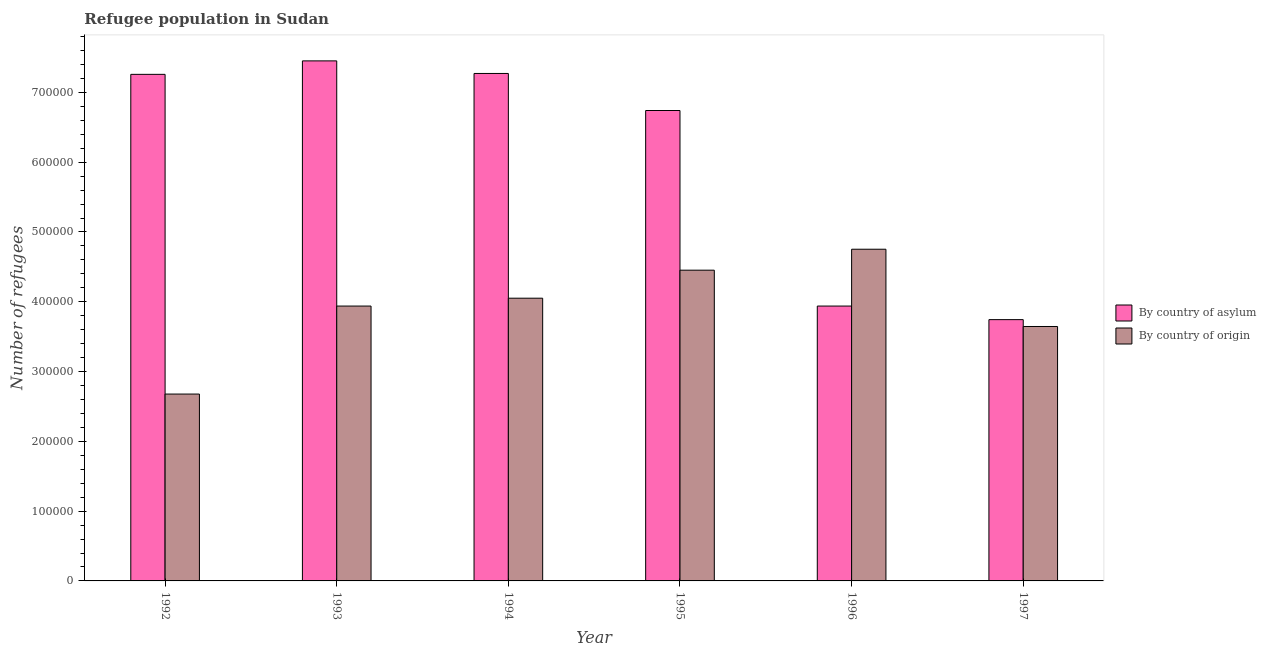How many different coloured bars are there?
Your response must be concise. 2. Are the number of bars on each tick of the X-axis equal?
Provide a short and direct response. Yes. How many bars are there on the 2nd tick from the left?
Your answer should be compact. 2. How many bars are there on the 4th tick from the right?
Offer a terse response. 2. In how many cases, is the number of bars for a given year not equal to the number of legend labels?
Give a very brief answer. 0. What is the number of refugees by country of origin in 1993?
Your answer should be very brief. 3.94e+05. Across all years, what is the maximum number of refugees by country of asylum?
Provide a succinct answer. 7.45e+05. Across all years, what is the minimum number of refugees by country of origin?
Keep it short and to the point. 2.68e+05. In which year was the number of refugees by country of origin maximum?
Provide a succinct answer. 1996. In which year was the number of refugees by country of origin minimum?
Make the answer very short. 1992. What is the total number of refugees by country of origin in the graph?
Keep it short and to the point. 2.35e+06. What is the difference between the number of refugees by country of asylum in 1993 and that in 1997?
Give a very brief answer. 3.71e+05. What is the difference between the number of refugees by country of asylum in 1994 and the number of refugees by country of origin in 1995?
Make the answer very short. 5.31e+04. What is the average number of refugees by country of asylum per year?
Offer a very short reply. 6.07e+05. In how many years, is the number of refugees by country of asylum greater than 140000?
Ensure brevity in your answer.  6. What is the ratio of the number of refugees by country of asylum in 1994 to that in 1997?
Make the answer very short. 1.94. Is the number of refugees by country of asylum in 1995 less than that in 1997?
Your response must be concise. No. Is the difference between the number of refugees by country of origin in 1993 and 1995 greater than the difference between the number of refugees by country of asylum in 1993 and 1995?
Offer a terse response. No. What is the difference between the highest and the second highest number of refugees by country of origin?
Make the answer very short. 3.00e+04. What is the difference between the highest and the lowest number of refugees by country of origin?
Provide a short and direct response. 2.08e+05. In how many years, is the number of refugees by country of origin greater than the average number of refugees by country of origin taken over all years?
Your answer should be compact. 4. What does the 2nd bar from the left in 1995 represents?
Make the answer very short. By country of origin. What does the 2nd bar from the right in 1993 represents?
Provide a short and direct response. By country of asylum. How many bars are there?
Make the answer very short. 12. What is the difference between two consecutive major ticks on the Y-axis?
Your answer should be compact. 1.00e+05. Does the graph contain grids?
Make the answer very short. No. Where does the legend appear in the graph?
Your answer should be very brief. Center right. What is the title of the graph?
Provide a succinct answer. Refugee population in Sudan. Does "Start a business" appear as one of the legend labels in the graph?
Provide a short and direct response. No. What is the label or title of the X-axis?
Make the answer very short. Year. What is the label or title of the Y-axis?
Your answer should be compact. Number of refugees. What is the Number of refugees in By country of asylum in 1992?
Ensure brevity in your answer.  7.26e+05. What is the Number of refugees of By country of origin in 1992?
Your response must be concise. 2.68e+05. What is the Number of refugees of By country of asylum in 1993?
Give a very brief answer. 7.45e+05. What is the Number of refugees in By country of origin in 1993?
Offer a very short reply. 3.94e+05. What is the Number of refugees in By country of asylum in 1994?
Make the answer very short. 7.27e+05. What is the Number of refugees of By country of origin in 1994?
Your answer should be compact. 4.05e+05. What is the Number of refugees of By country of asylum in 1995?
Your answer should be very brief. 6.74e+05. What is the Number of refugees of By country of origin in 1995?
Your response must be concise. 4.45e+05. What is the Number of refugees of By country of asylum in 1996?
Keep it short and to the point. 3.94e+05. What is the Number of refugees in By country of origin in 1996?
Provide a succinct answer. 4.75e+05. What is the Number of refugees of By country of asylum in 1997?
Your response must be concise. 3.74e+05. What is the Number of refugees of By country of origin in 1997?
Your response must be concise. 3.65e+05. Across all years, what is the maximum Number of refugees in By country of asylum?
Offer a terse response. 7.45e+05. Across all years, what is the maximum Number of refugees in By country of origin?
Make the answer very short. 4.75e+05. Across all years, what is the minimum Number of refugees in By country of asylum?
Ensure brevity in your answer.  3.74e+05. Across all years, what is the minimum Number of refugees in By country of origin?
Make the answer very short. 2.68e+05. What is the total Number of refugees of By country of asylum in the graph?
Ensure brevity in your answer.  3.64e+06. What is the total Number of refugees of By country of origin in the graph?
Provide a short and direct response. 2.35e+06. What is the difference between the Number of refugees of By country of asylum in 1992 and that in 1993?
Provide a succinct answer. -1.93e+04. What is the difference between the Number of refugees of By country of origin in 1992 and that in 1993?
Ensure brevity in your answer.  -1.26e+05. What is the difference between the Number of refugees of By country of asylum in 1992 and that in 1994?
Your response must be concise. -1274. What is the difference between the Number of refugees in By country of origin in 1992 and that in 1994?
Make the answer very short. -1.37e+05. What is the difference between the Number of refugees in By country of asylum in 1992 and that in 1995?
Offer a very short reply. 5.18e+04. What is the difference between the Number of refugees in By country of origin in 1992 and that in 1995?
Give a very brief answer. -1.78e+05. What is the difference between the Number of refugees in By country of asylum in 1992 and that in 1996?
Give a very brief answer. 3.32e+05. What is the difference between the Number of refugees of By country of origin in 1992 and that in 1996?
Offer a terse response. -2.08e+05. What is the difference between the Number of refugees of By country of asylum in 1992 and that in 1997?
Your answer should be compact. 3.51e+05. What is the difference between the Number of refugees of By country of origin in 1992 and that in 1997?
Make the answer very short. -9.68e+04. What is the difference between the Number of refugees in By country of asylum in 1993 and that in 1994?
Your answer should be very brief. 1.80e+04. What is the difference between the Number of refugees of By country of origin in 1993 and that in 1994?
Ensure brevity in your answer.  -1.13e+04. What is the difference between the Number of refugees of By country of asylum in 1993 and that in 1995?
Your answer should be very brief. 7.11e+04. What is the difference between the Number of refugees of By country of origin in 1993 and that in 1995?
Your response must be concise. -5.14e+04. What is the difference between the Number of refugees in By country of asylum in 1993 and that in 1996?
Offer a very short reply. 3.51e+05. What is the difference between the Number of refugees of By country of origin in 1993 and that in 1996?
Offer a terse response. -8.14e+04. What is the difference between the Number of refugees in By country of asylum in 1993 and that in 1997?
Make the answer very short. 3.71e+05. What is the difference between the Number of refugees in By country of origin in 1993 and that in 1997?
Provide a short and direct response. 2.93e+04. What is the difference between the Number of refugees of By country of asylum in 1994 and that in 1995?
Give a very brief answer. 5.31e+04. What is the difference between the Number of refugees in By country of origin in 1994 and that in 1995?
Offer a terse response. -4.01e+04. What is the difference between the Number of refugees in By country of asylum in 1994 and that in 1996?
Make the answer very short. 3.33e+05. What is the difference between the Number of refugees in By country of origin in 1994 and that in 1996?
Ensure brevity in your answer.  -7.02e+04. What is the difference between the Number of refugees in By country of asylum in 1994 and that in 1997?
Your answer should be very brief. 3.53e+05. What is the difference between the Number of refugees of By country of origin in 1994 and that in 1997?
Your answer should be very brief. 4.05e+04. What is the difference between the Number of refugees in By country of asylum in 1995 and that in 1996?
Keep it short and to the point. 2.80e+05. What is the difference between the Number of refugees of By country of origin in 1995 and that in 1996?
Offer a terse response. -3.00e+04. What is the difference between the Number of refugees of By country of asylum in 1995 and that in 1997?
Keep it short and to the point. 3.00e+05. What is the difference between the Number of refugees of By country of origin in 1995 and that in 1997?
Provide a short and direct response. 8.07e+04. What is the difference between the Number of refugees in By country of asylum in 1996 and that in 1997?
Keep it short and to the point. 1.95e+04. What is the difference between the Number of refugees of By country of origin in 1996 and that in 1997?
Your answer should be compact. 1.11e+05. What is the difference between the Number of refugees in By country of asylum in 1992 and the Number of refugees in By country of origin in 1993?
Make the answer very short. 3.32e+05. What is the difference between the Number of refugees in By country of asylum in 1992 and the Number of refugees in By country of origin in 1994?
Provide a short and direct response. 3.21e+05. What is the difference between the Number of refugees in By country of asylum in 1992 and the Number of refugees in By country of origin in 1995?
Your response must be concise. 2.81e+05. What is the difference between the Number of refugees of By country of asylum in 1992 and the Number of refugees of By country of origin in 1996?
Offer a terse response. 2.51e+05. What is the difference between the Number of refugees in By country of asylum in 1992 and the Number of refugees in By country of origin in 1997?
Ensure brevity in your answer.  3.61e+05. What is the difference between the Number of refugees of By country of asylum in 1993 and the Number of refugees of By country of origin in 1994?
Offer a very short reply. 3.40e+05. What is the difference between the Number of refugees of By country of asylum in 1993 and the Number of refugees of By country of origin in 1995?
Offer a very short reply. 3.00e+05. What is the difference between the Number of refugees in By country of asylum in 1993 and the Number of refugees in By country of origin in 1996?
Your answer should be very brief. 2.70e+05. What is the difference between the Number of refugees in By country of asylum in 1993 and the Number of refugees in By country of origin in 1997?
Offer a terse response. 3.81e+05. What is the difference between the Number of refugees of By country of asylum in 1994 and the Number of refugees of By country of origin in 1995?
Your response must be concise. 2.82e+05. What is the difference between the Number of refugees of By country of asylum in 1994 and the Number of refugees of By country of origin in 1996?
Your answer should be very brief. 2.52e+05. What is the difference between the Number of refugees in By country of asylum in 1994 and the Number of refugees in By country of origin in 1997?
Offer a terse response. 3.63e+05. What is the difference between the Number of refugees in By country of asylum in 1995 and the Number of refugees in By country of origin in 1996?
Your response must be concise. 1.99e+05. What is the difference between the Number of refugees in By country of asylum in 1995 and the Number of refugees in By country of origin in 1997?
Ensure brevity in your answer.  3.09e+05. What is the difference between the Number of refugees in By country of asylum in 1996 and the Number of refugees in By country of origin in 1997?
Make the answer very short. 2.93e+04. What is the average Number of refugees of By country of asylum per year?
Ensure brevity in your answer.  6.07e+05. What is the average Number of refugees of By country of origin per year?
Your answer should be very brief. 3.92e+05. In the year 1992, what is the difference between the Number of refugees of By country of asylum and Number of refugees of By country of origin?
Your answer should be very brief. 4.58e+05. In the year 1993, what is the difference between the Number of refugees of By country of asylum and Number of refugees of By country of origin?
Ensure brevity in your answer.  3.51e+05. In the year 1994, what is the difference between the Number of refugees of By country of asylum and Number of refugees of By country of origin?
Offer a terse response. 3.22e+05. In the year 1995, what is the difference between the Number of refugees in By country of asylum and Number of refugees in By country of origin?
Your answer should be very brief. 2.29e+05. In the year 1996, what is the difference between the Number of refugees in By country of asylum and Number of refugees in By country of origin?
Offer a terse response. -8.14e+04. In the year 1997, what is the difference between the Number of refugees of By country of asylum and Number of refugees of By country of origin?
Keep it short and to the point. 9826. What is the ratio of the Number of refugees of By country of asylum in 1992 to that in 1993?
Offer a very short reply. 0.97. What is the ratio of the Number of refugees in By country of origin in 1992 to that in 1993?
Offer a very short reply. 0.68. What is the ratio of the Number of refugees of By country of asylum in 1992 to that in 1994?
Offer a terse response. 1. What is the ratio of the Number of refugees of By country of origin in 1992 to that in 1994?
Provide a succinct answer. 0.66. What is the ratio of the Number of refugees of By country of asylum in 1992 to that in 1995?
Your answer should be compact. 1.08. What is the ratio of the Number of refugees in By country of origin in 1992 to that in 1995?
Your response must be concise. 0.6. What is the ratio of the Number of refugees of By country of asylum in 1992 to that in 1996?
Offer a terse response. 1.84. What is the ratio of the Number of refugees in By country of origin in 1992 to that in 1996?
Offer a very short reply. 0.56. What is the ratio of the Number of refugees in By country of asylum in 1992 to that in 1997?
Offer a terse response. 1.94. What is the ratio of the Number of refugees in By country of origin in 1992 to that in 1997?
Provide a short and direct response. 0.73. What is the ratio of the Number of refugees of By country of asylum in 1993 to that in 1994?
Make the answer very short. 1.02. What is the ratio of the Number of refugees in By country of origin in 1993 to that in 1994?
Offer a very short reply. 0.97. What is the ratio of the Number of refugees in By country of asylum in 1993 to that in 1995?
Offer a terse response. 1.11. What is the ratio of the Number of refugees in By country of origin in 1993 to that in 1995?
Your answer should be very brief. 0.88. What is the ratio of the Number of refugees in By country of asylum in 1993 to that in 1996?
Offer a terse response. 1.89. What is the ratio of the Number of refugees in By country of origin in 1993 to that in 1996?
Provide a short and direct response. 0.83. What is the ratio of the Number of refugees in By country of asylum in 1993 to that in 1997?
Your answer should be very brief. 1.99. What is the ratio of the Number of refugees in By country of origin in 1993 to that in 1997?
Keep it short and to the point. 1.08. What is the ratio of the Number of refugees of By country of asylum in 1994 to that in 1995?
Offer a very short reply. 1.08. What is the ratio of the Number of refugees of By country of origin in 1994 to that in 1995?
Provide a short and direct response. 0.91. What is the ratio of the Number of refugees of By country of asylum in 1994 to that in 1996?
Your response must be concise. 1.85. What is the ratio of the Number of refugees in By country of origin in 1994 to that in 1996?
Offer a very short reply. 0.85. What is the ratio of the Number of refugees in By country of asylum in 1994 to that in 1997?
Your response must be concise. 1.94. What is the ratio of the Number of refugees in By country of origin in 1994 to that in 1997?
Provide a succinct answer. 1.11. What is the ratio of the Number of refugees of By country of asylum in 1995 to that in 1996?
Provide a succinct answer. 1.71. What is the ratio of the Number of refugees in By country of origin in 1995 to that in 1996?
Give a very brief answer. 0.94. What is the ratio of the Number of refugees in By country of asylum in 1995 to that in 1997?
Offer a very short reply. 1.8. What is the ratio of the Number of refugees of By country of origin in 1995 to that in 1997?
Provide a succinct answer. 1.22. What is the ratio of the Number of refugees of By country of asylum in 1996 to that in 1997?
Offer a terse response. 1.05. What is the ratio of the Number of refugees in By country of origin in 1996 to that in 1997?
Offer a terse response. 1.3. What is the difference between the highest and the second highest Number of refugees of By country of asylum?
Give a very brief answer. 1.80e+04. What is the difference between the highest and the second highest Number of refugees in By country of origin?
Give a very brief answer. 3.00e+04. What is the difference between the highest and the lowest Number of refugees of By country of asylum?
Your answer should be very brief. 3.71e+05. What is the difference between the highest and the lowest Number of refugees of By country of origin?
Your answer should be very brief. 2.08e+05. 